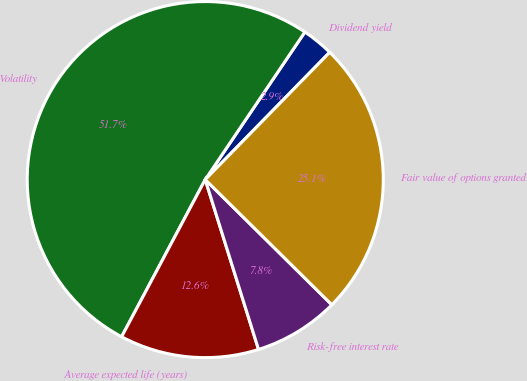<chart> <loc_0><loc_0><loc_500><loc_500><pie_chart><fcel>Dividend yield<fcel>Volatility<fcel>Average expected life (years)<fcel>Risk-free interest rate<fcel>Fair value of options granted<nl><fcel>2.87%<fcel>51.67%<fcel>12.62%<fcel>7.75%<fcel>25.09%<nl></chart> 